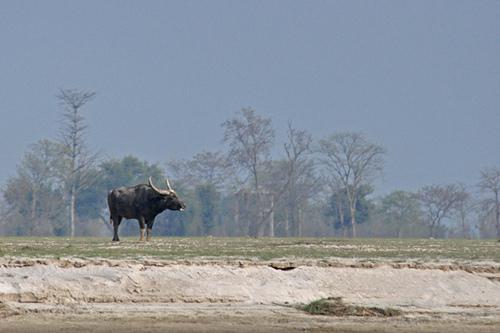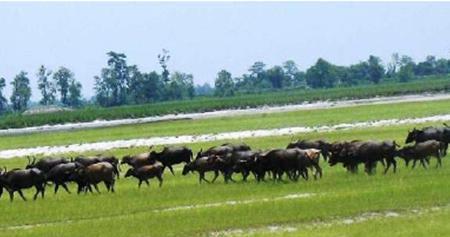The first image is the image on the left, the second image is the image on the right. Analyze the images presented: Is the assertion "At least one of the images includes a body of water that there are no water buffalos in." valid? Answer yes or no. No. The first image is the image on the left, the second image is the image on the right. Given the left and right images, does the statement "At least one image in the pair contains only one ox." hold true? Answer yes or no. Yes. 